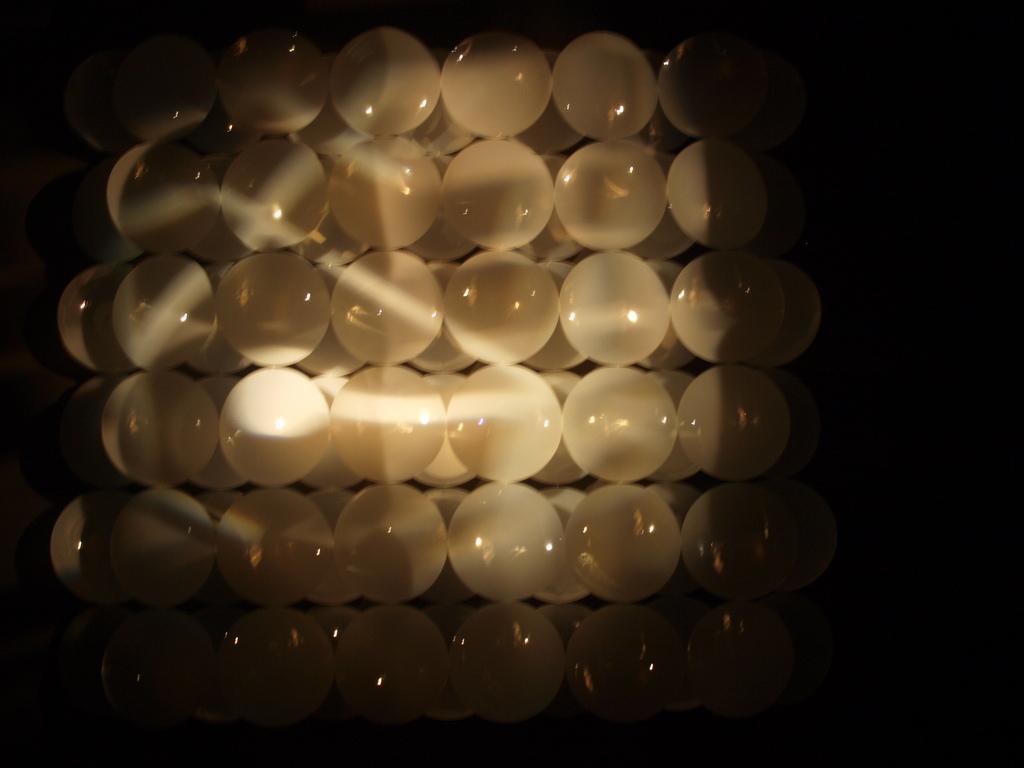In one or two sentences, can you explain what this image depicts? These are the white color balls. 